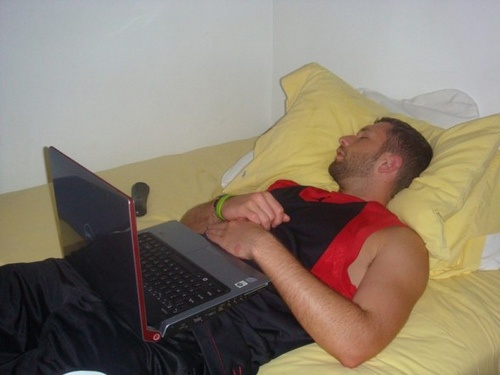Describe the objects in this image and their specific colors. I can see people in darkgray, black, brown, and tan tones, bed in darkgray, tan, and olive tones, laptop in darkgray, black, gray, and maroon tones, remote in darkgray, black, and gray tones, and cell phone in darkgray, black, and gray tones in this image. 